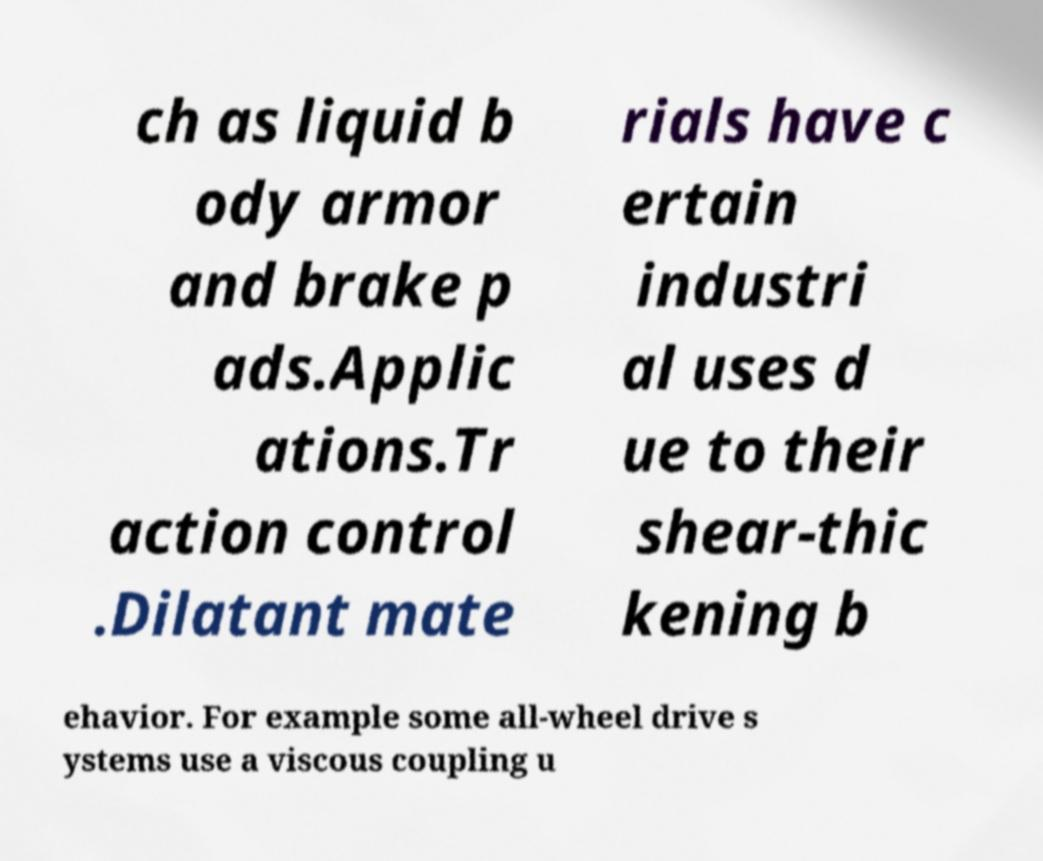Please read and relay the text visible in this image. What does it say? ch as liquid b ody armor and brake p ads.Applic ations.Tr action control .Dilatant mate rials have c ertain industri al uses d ue to their shear-thic kening b ehavior. For example some all-wheel drive s ystems use a viscous coupling u 